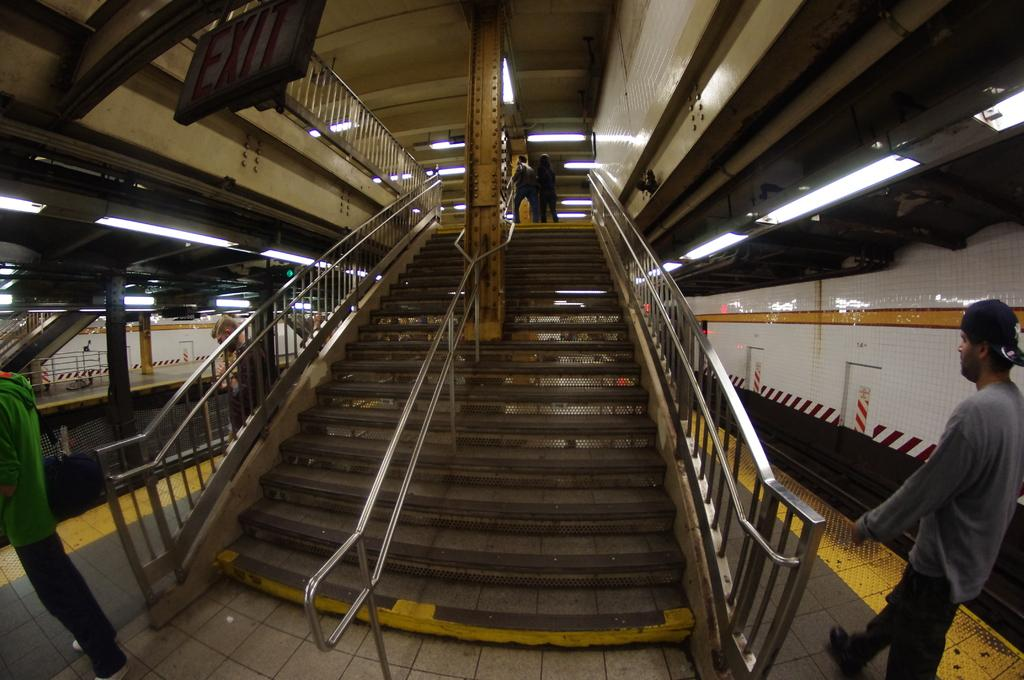What is located on the right side of the image? There is a man on the right side of the image. What can be seen in the middle of the image? There is a staircase in the middle of the image. What is visible in the image that provides illumination? There are lights visible in the image. What is at the top of the image? There is a board at the top of the image. What is the color of the poster in the image? The poster is white. What type of notebook is the man using for his activity in the image? There is no notebook or activity visible in the image; it only features a man, a staircase, lights, a board, and a white poster. Can you tell me how many tramps are present in the image? There are no tramps present in the image. 